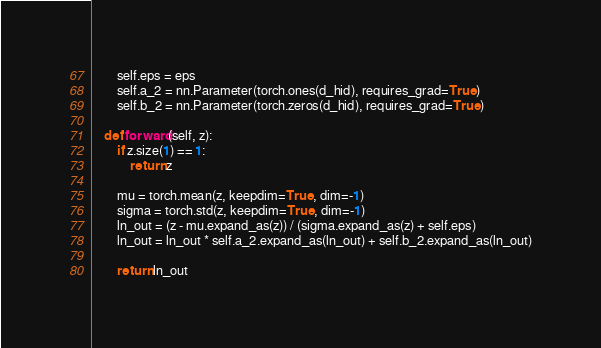<code> <loc_0><loc_0><loc_500><loc_500><_Python_>        self.eps = eps
        self.a_2 = nn.Parameter(torch.ones(d_hid), requires_grad=True)
        self.b_2 = nn.Parameter(torch.zeros(d_hid), requires_grad=True)

    def forward(self, z):
        if z.size(1) == 1:
            return z

        mu = torch.mean(z, keepdim=True, dim=-1)
        sigma = torch.std(z, keepdim=True, dim=-1)
        ln_out = (z - mu.expand_as(z)) / (sigma.expand_as(z) + self.eps)
        ln_out = ln_out * self.a_2.expand_as(ln_out) + self.b_2.expand_as(ln_out)

        return ln_out</code> 